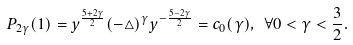<formula> <loc_0><loc_0><loc_500><loc_500>P _ { 2 \gamma } ( 1 ) = y ^ { \frac { 5 + 2 \gamma } { 2 } } ( - \triangle ) ^ { \gamma } y ^ { - \frac { 5 - 2 \gamma } { 2 } } = c _ { 0 } ( \gamma ) , \ \forall 0 < \gamma < \frac { 3 } { 2 } .</formula> 